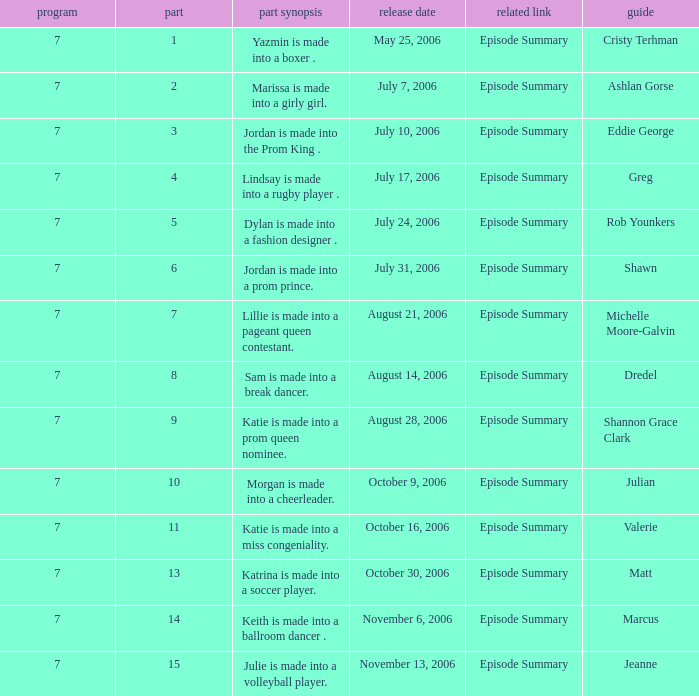What the summary of episode 15? Julie is made into a volleyball player. 